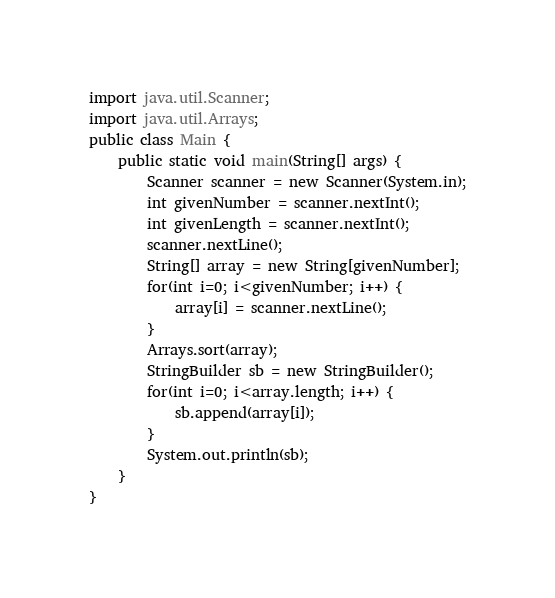<code> <loc_0><loc_0><loc_500><loc_500><_Java_>import java.util.Scanner;
import java.util.Arrays;
public class Main {
    public static void main(String[] args) {
        Scanner scanner = new Scanner(System.in);
        int givenNumber = scanner.nextInt();
        int givenLength = scanner.nextInt();
        scanner.nextLine();
        String[] array = new String[givenNumber];
        for(int i=0; i<givenNumber; i++) {
            array[i] = scanner.nextLine();
        }
        Arrays.sort(array);
        StringBuilder sb = new StringBuilder();
        for(int i=0; i<array.length; i++) {
            sb.append(array[i]);
        }
        System.out.println(sb);
    }
}
</code> 